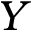<formula> <loc_0><loc_0><loc_500><loc_500>Y</formula> 